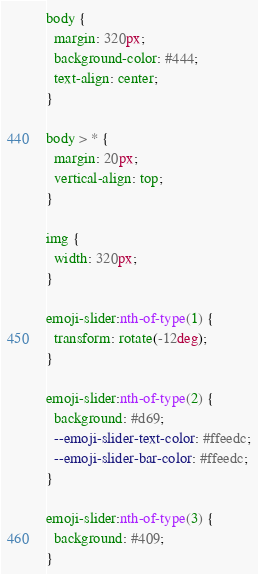Convert code to text. <code><loc_0><loc_0><loc_500><loc_500><_CSS_>body {
  margin: 320px;
  background-color: #444;
  text-align: center;
}

body > * {
  margin: 20px;
  vertical-align: top;
}

img {
  width: 320px;
}

emoji-slider:nth-of-type(1) {
  transform: rotate(-12deg);
}

emoji-slider:nth-of-type(2) {
  background: #d69;
  --emoji-slider-text-color: #ffeedc;
  --emoji-slider-bar-color: #ffeedc;
}

emoji-slider:nth-of-type(3) {
  background: #409;
}</code> 